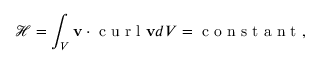Convert formula to latex. <formula><loc_0><loc_0><loc_500><loc_500>\mathcal { H } = \int _ { V } v \cdot c u r l v d V = c o n s t a n t ,</formula> 